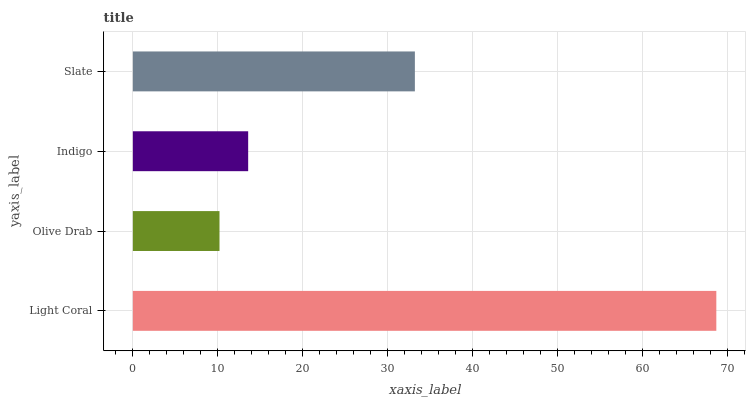Is Olive Drab the minimum?
Answer yes or no. Yes. Is Light Coral the maximum?
Answer yes or no. Yes. Is Indigo the minimum?
Answer yes or no. No. Is Indigo the maximum?
Answer yes or no. No. Is Indigo greater than Olive Drab?
Answer yes or no. Yes. Is Olive Drab less than Indigo?
Answer yes or no. Yes. Is Olive Drab greater than Indigo?
Answer yes or no. No. Is Indigo less than Olive Drab?
Answer yes or no. No. Is Slate the high median?
Answer yes or no. Yes. Is Indigo the low median?
Answer yes or no. Yes. Is Olive Drab the high median?
Answer yes or no. No. Is Olive Drab the low median?
Answer yes or no. No. 